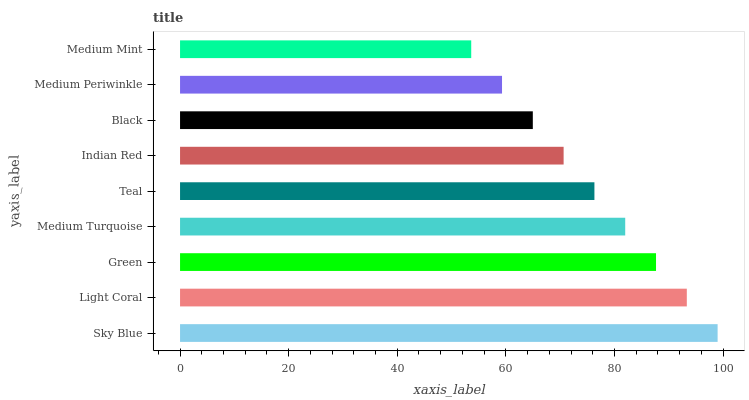Is Medium Mint the minimum?
Answer yes or no. Yes. Is Sky Blue the maximum?
Answer yes or no. Yes. Is Light Coral the minimum?
Answer yes or no. No. Is Light Coral the maximum?
Answer yes or no. No. Is Sky Blue greater than Light Coral?
Answer yes or no. Yes. Is Light Coral less than Sky Blue?
Answer yes or no. Yes. Is Light Coral greater than Sky Blue?
Answer yes or no. No. Is Sky Blue less than Light Coral?
Answer yes or no. No. Is Teal the high median?
Answer yes or no. Yes. Is Teal the low median?
Answer yes or no. Yes. Is Black the high median?
Answer yes or no. No. Is Black the low median?
Answer yes or no. No. 